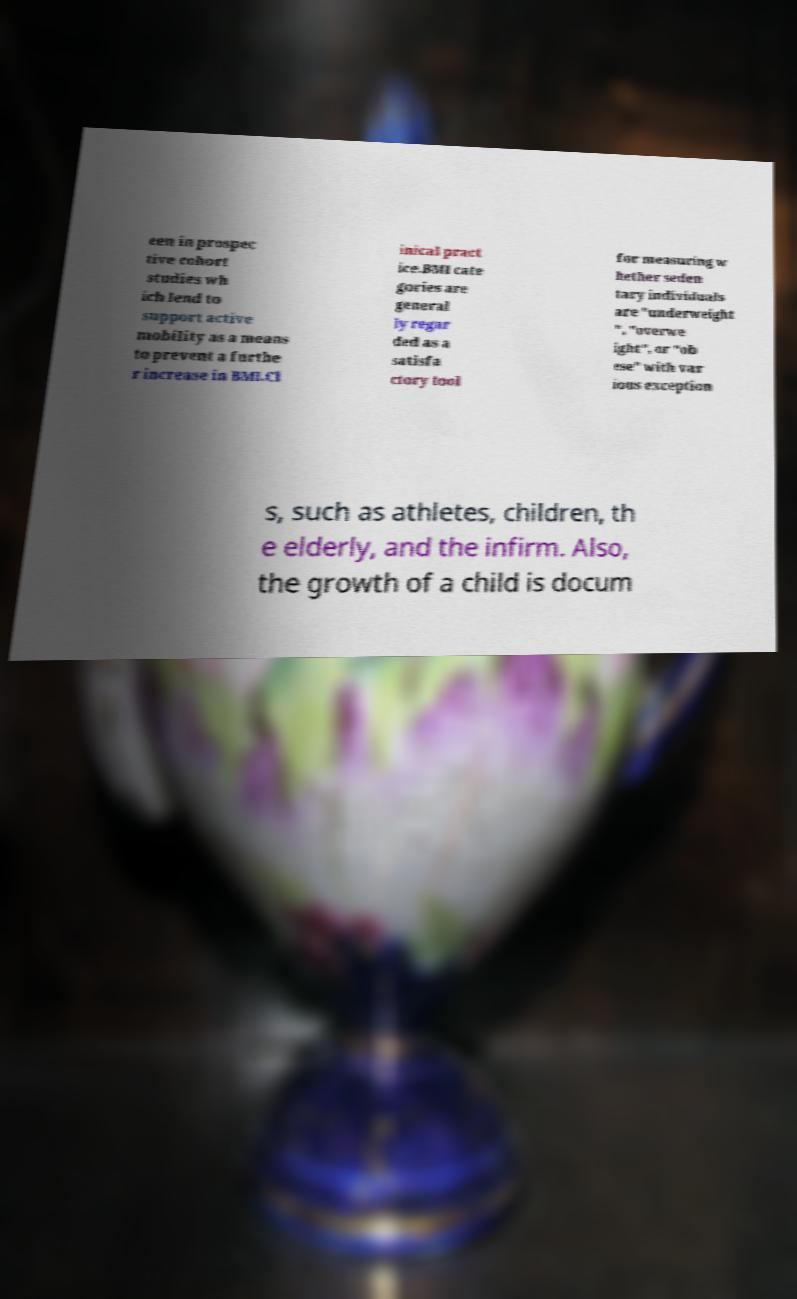There's text embedded in this image that I need extracted. Can you transcribe it verbatim? een in prospec tive cohort studies wh ich lend to support active mobility as a means to prevent a furthe r increase in BMI.Cl inical pract ice.BMI cate gories are general ly regar ded as a satisfa ctory tool for measuring w hether seden tary individuals are "underweight ", "overwe ight", or "ob ese" with var ious exception s, such as athletes, children, th e elderly, and the infirm. Also, the growth of a child is docum 